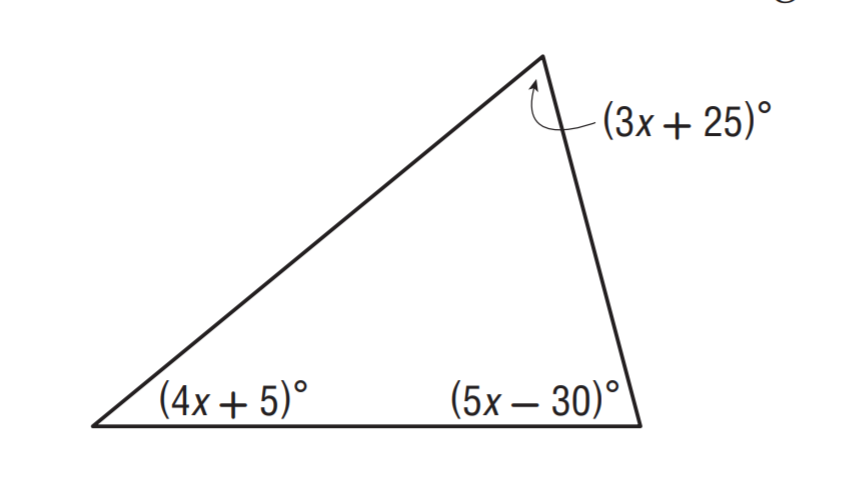Answer the mathemtical geometry problem and directly provide the correct option letter.
Question: Solve for x.
Choices: A: 10 B: 15 C: 25 D: 30 B 